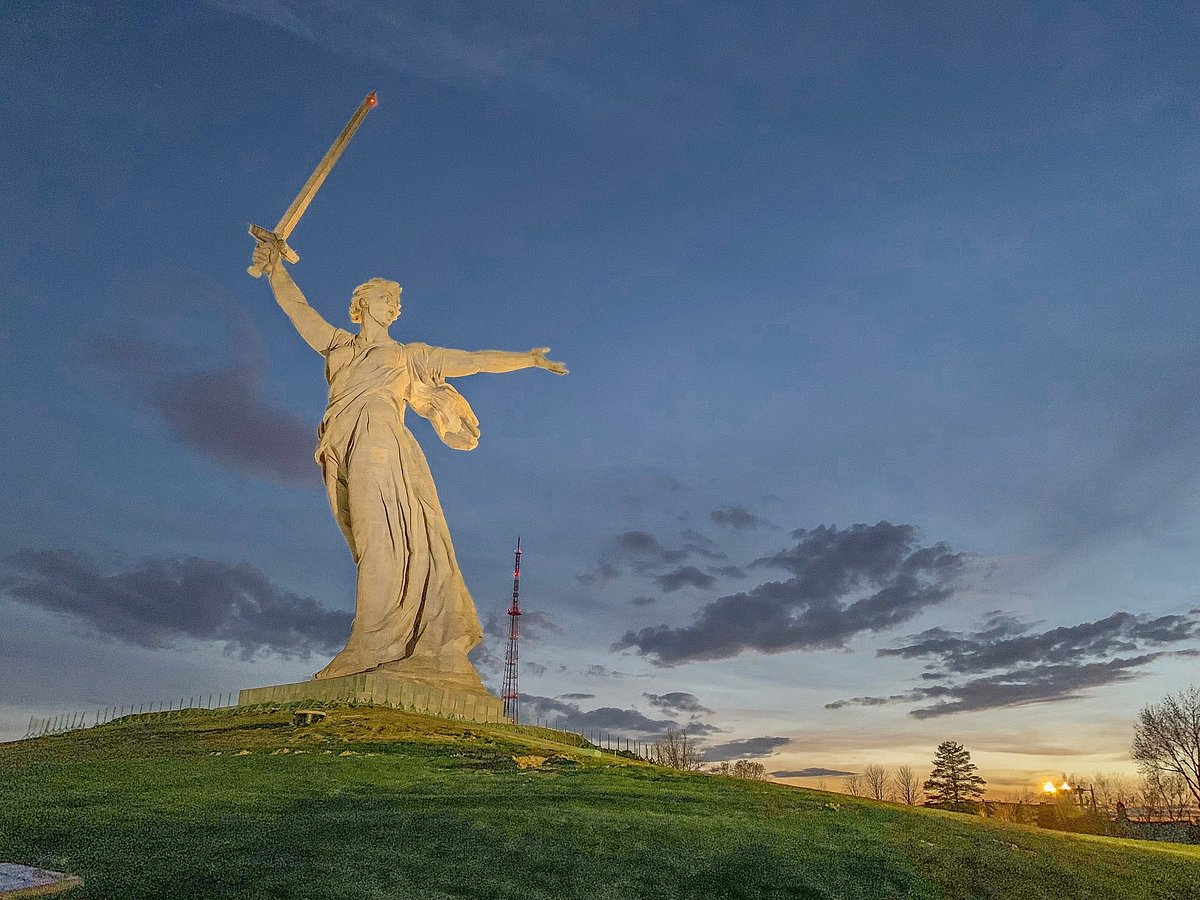What role does the sky play in the overall effect of this image? The sky plays a crucial role in the overall effect of this image, acting as a dynamic and vibrant backdrop that complements the statue's grandeur. The twilight sky, with its blend of orange and blue hues, creates a dramatic and serene atmosphere, enhancing the statue's imposing presence. The clouds add depth and texture, contributing to the sense of vastness and scale. The interaction of the setting sun's light with the statue's golden sword adds a luminous quality, symbolizing hope and resilience. Overall, the sky imbues the scene with emotional resonance, elevating the monument's visual impact and reinforcing its symbolic significance. 